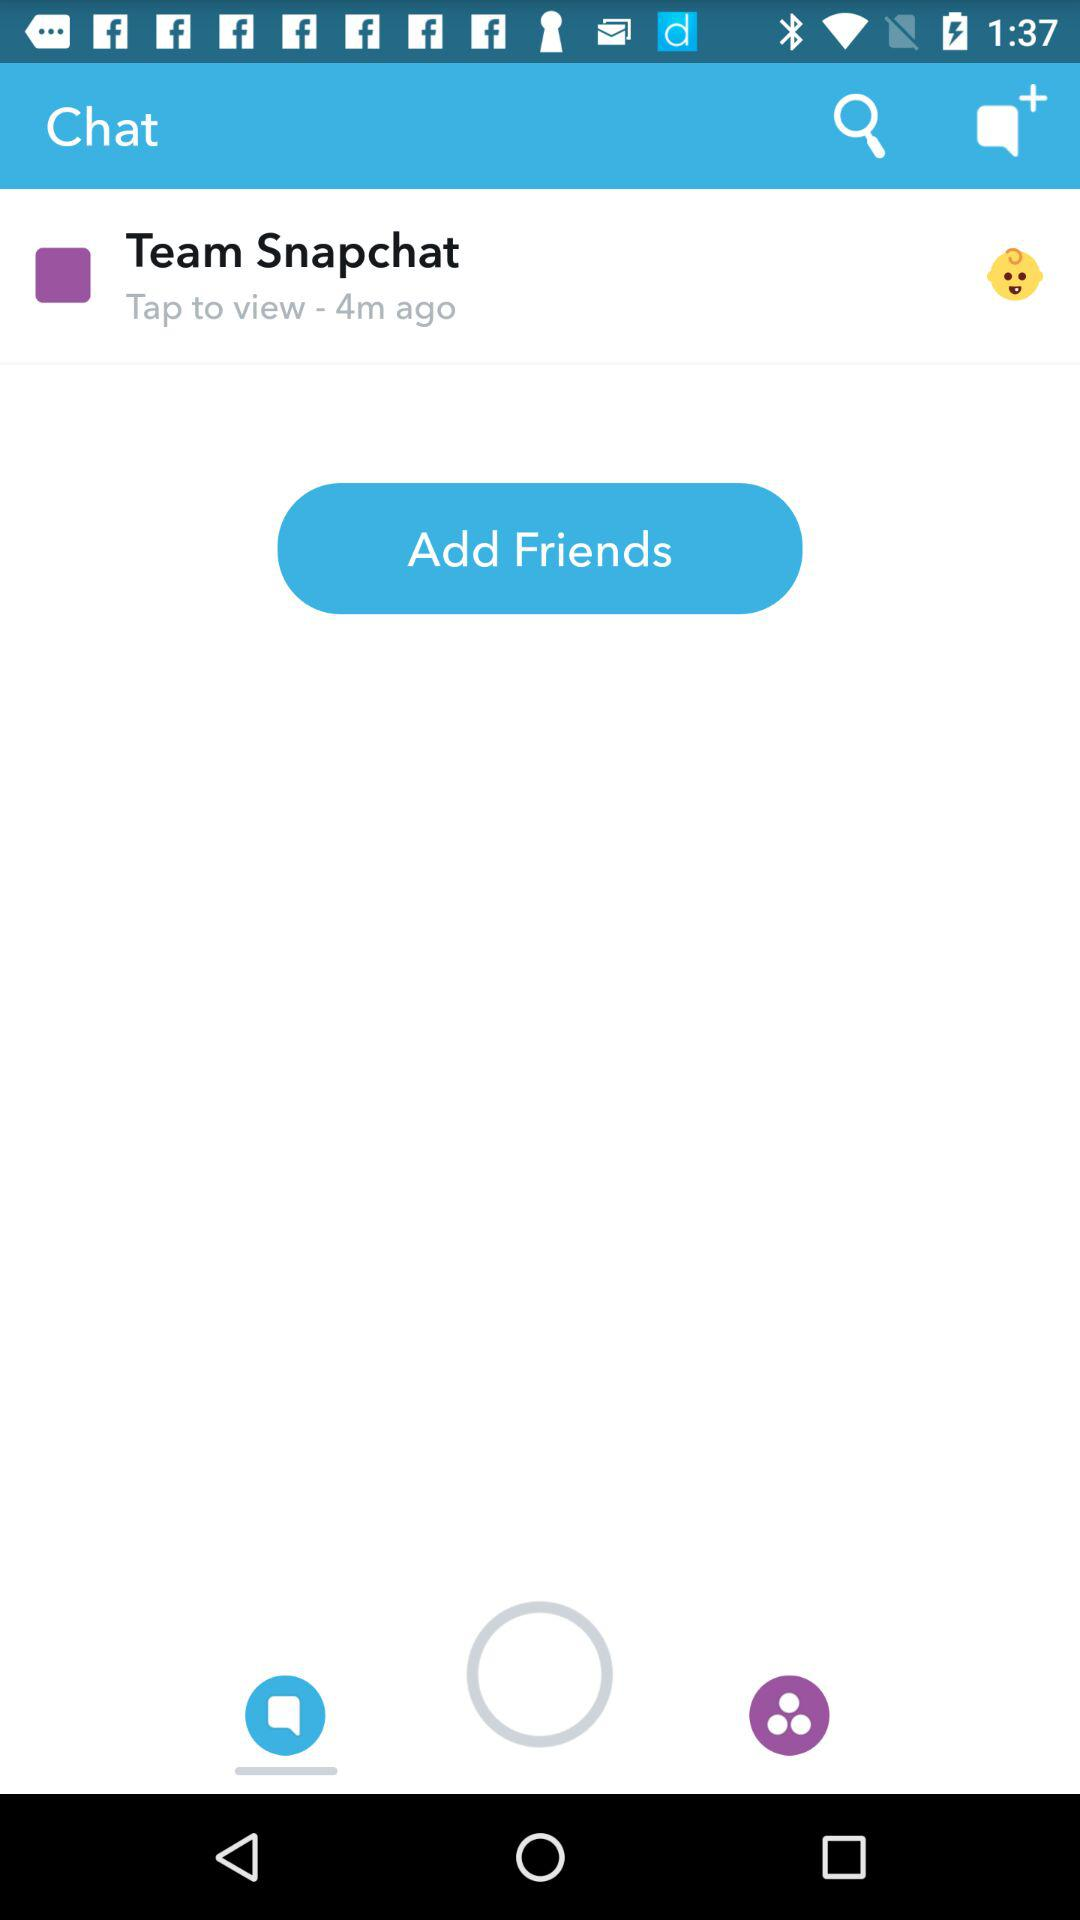How many friends can be added in total?
When the provided information is insufficient, respond with <no answer>. <no answer> 